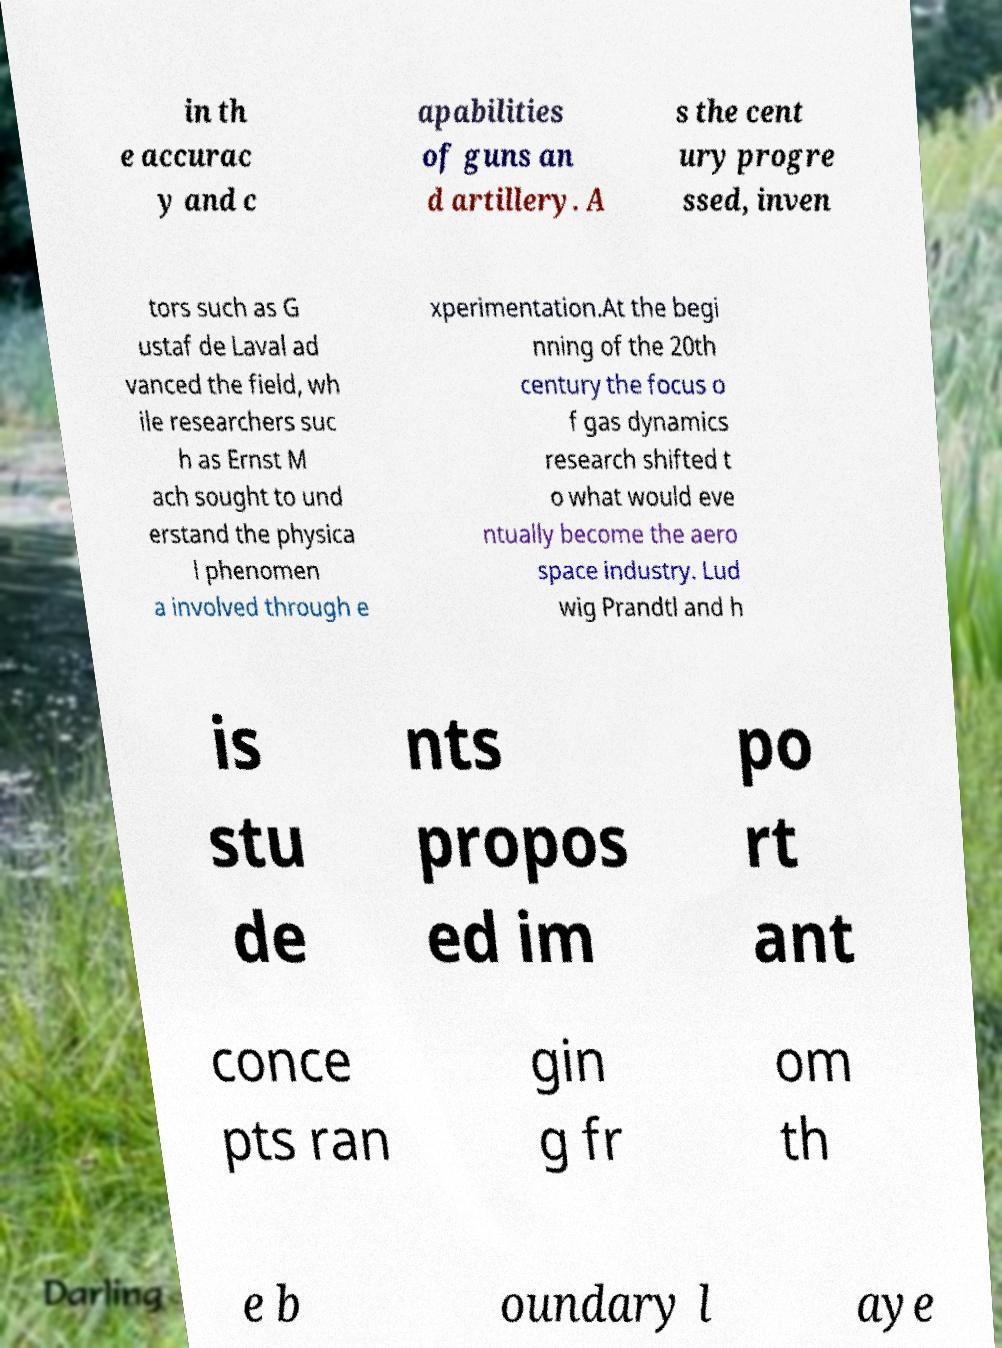Could you assist in decoding the text presented in this image and type it out clearly? in th e accurac y and c apabilities of guns an d artillery. A s the cent ury progre ssed, inven tors such as G ustaf de Laval ad vanced the field, wh ile researchers suc h as Ernst M ach sought to und erstand the physica l phenomen a involved through e xperimentation.At the begi nning of the 20th century the focus o f gas dynamics research shifted t o what would eve ntually become the aero space industry. Lud wig Prandtl and h is stu de nts propos ed im po rt ant conce pts ran gin g fr om th e b oundary l aye 